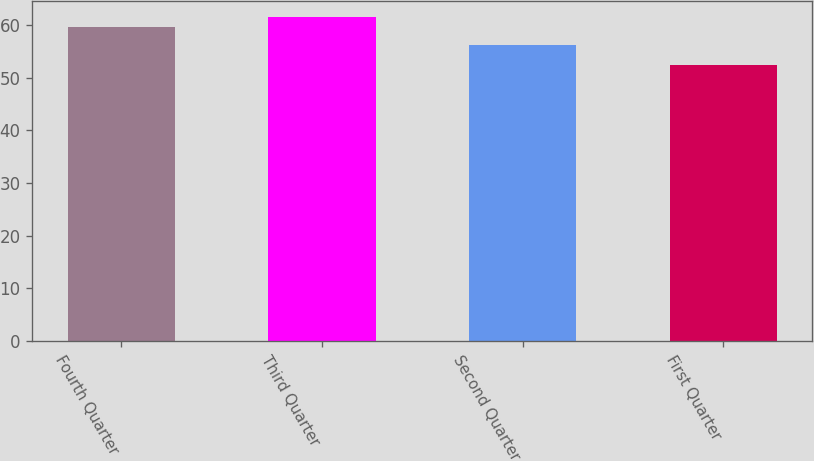Convert chart. <chart><loc_0><loc_0><loc_500><loc_500><bar_chart><fcel>Fourth Quarter<fcel>Third Quarter<fcel>Second Quarter<fcel>First Quarter<nl><fcel>59.66<fcel>61.48<fcel>56.29<fcel>52.5<nl></chart> 